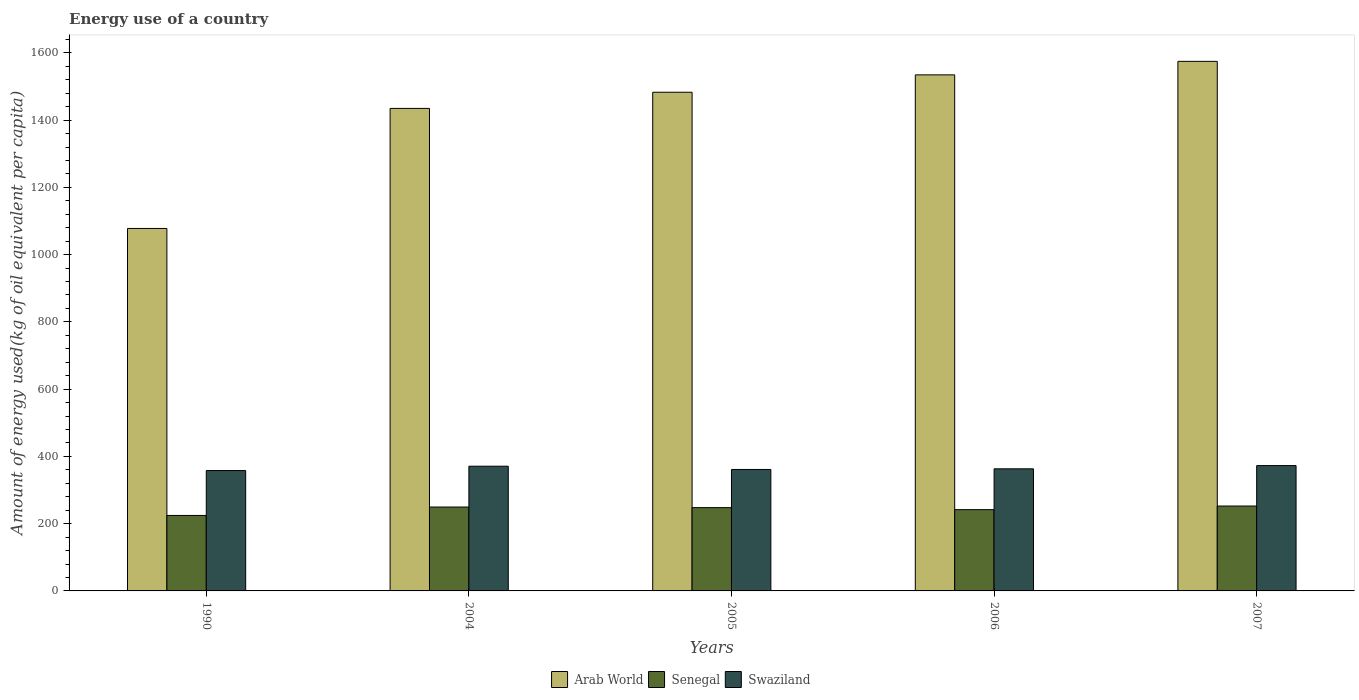How many different coloured bars are there?
Your answer should be very brief. 3. How many groups of bars are there?
Provide a succinct answer. 5. Are the number of bars per tick equal to the number of legend labels?
Keep it short and to the point. Yes. Are the number of bars on each tick of the X-axis equal?
Ensure brevity in your answer.  Yes. How many bars are there on the 2nd tick from the right?
Provide a short and direct response. 3. What is the amount of energy used in in Arab World in 2006?
Keep it short and to the point. 1534.62. Across all years, what is the maximum amount of energy used in in Senegal?
Offer a very short reply. 252.41. Across all years, what is the minimum amount of energy used in in Senegal?
Your answer should be very brief. 224.43. What is the total amount of energy used in in Senegal in the graph?
Offer a terse response. 1215.62. What is the difference between the amount of energy used in in Swaziland in 1990 and that in 2004?
Your answer should be very brief. -12.92. What is the difference between the amount of energy used in in Swaziland in 1990 and the amount of energy used in in Arab World in 2004?
Give a very brief answer. -1076.91. What is the average amount of energy used in in Senegal per year?
Ensure brevity in your answer.  243.12. In the year 2006, what is the difference between the amount of energy used in in Swaziland and amount of energy used in in Arab World?
Make the answer very short. -1171.54. What is the ratio of the amount of energy used in in Swaziland in 2005 to that in 2007?
Give a very brief answer. 0.97. Is the amount of energy used in in Arab World in 1990 less than that in 2004?
Your answer should be compact. Yes. What is the difference between the highest and the second highest amount of energy used in in Swaziland?
Provide a short and direct response. 1.88. What is the difference between the highest and the lowest amount of energy used in in Senegal?
Your answer should be compact. 27.98. In how many years, is the amount of energy used in in Senegal greater than the average amount of energy used in in Senegal taken over all years?
Give a very brief answer. 3. Is the sum of the amount of energy used in in Swaziland in 2004 and 2005 greater than the maximum amount of energy used in in Arab World across all years?
Your answer should be compact. No. What does the 3rd bar from the left in 2006 represents?
Offer a terse response. Swaziland. What does the 2nd bar from the right in 2006 represents?
Offer a terse response. Senegal. How many bars are there?
Provide a short and direct response. 15. Are all the bars in the graph horizontal?
Offer a very short reply. No. How many years are there in the graph?
Provide a succinct answer. 5. Are the values on the major ticks of Y-axis written in scientific E-notation?
Offer a very short reply. No. Does the graph contain any zero values?
Your answer should be compact. No. Where does the legend appear in the graph?
Your answer should be very brief. Bottom center. What is the title of the graph?
Your response must be concise. Energy use of a country. What is the label or title of the Y-axis?
Offer a very short reply. Amount of energy used(kg of oil equivalent per capita). What is the Amount of energy used(kg of oil equivalent per capita) of Arab World in 1990?
Offer a terse response. 1077.86. What is the Amount of energy used(kg of oil equivalent per capita) in Senegal in 1990?
Give a very brief answer. 224.43. What is the Amount of energy used(kg of oil equivalent per capita) of Swaziland in 1990?
Provide a succinct answer. 357.93. What is the Amount of energy used(kg of oil equivalent per capita) of Arab World in 2004?
Provide a succinct answer. 1434.84. What is the Amount of energy used(kg of oil equivalent per capita) of Senegal in 2004?
Ensure brevity in your answer.  249.43. What is the Amount of energy used(kg of oil equivalent per capita) in Swaziland in 2004?
Your answer should be very brief. 370.85. What is the Amount of energy used(kg of oil equivalent per capita) of Arab World in 2005?
Make the answer very short. 1482.94. What is the Amount of energy used(kg of oil equivalent per capita) of Senegal in 2005?
Provide a short and direct response. 247.66. What is the Amount of energy used(kg of oil equivalent per capita) in Swaziland in 2005?
Give a very brief answer. 361.2. What is the Amount of energy used(kg of oil equivalent per capita) of Arab World in 2006?
Offer a terse response. 1534.62. What is the Amount of energy used(kg of oil equivalent per capita) of Senegal in 2006?
Offer a very short reply. 241.68. What is the Amount of energy used(kg of oil equivalent per capita) in Swaziland in 2006?
Your answer should be compact. 363.08. What is the Amount of energy used(kg of oil equivalent per capita) of Arab World in 2007?
Your response must be concise. 1574.79. What is the Amount of energy used(kg of oil equivalent per capita) in Senegal in 2007?
Your response must be concise. 252.41. What is the Amount of energy used(kg of oil equivalent per capita) of Swaziland in 2007?
Give a very brief answer. 372.74. Across all years, what is the maximum Amount of energy used(kg of oil equivalent per capita) of Arab World?
Keep it short and to the point. 1574.79. Across all years, what is the maximum Amount of energy used(kg of oil equivalent per capita) of Senegal?
Offer a terse response. 252.41. Across all years, what is the maximum Amount of energy used(kg of oil equivalent per capita) of Swaziland?
Offer a very short reply. 372.74. Across all years, what is the minimum Amount of energy used(kg of oil equivalent per capita) of Arab World?
Your answer should be very brief. 1077.86. Across all years, what is the minimum Amount of energy used(kg of oil equivalent per capita) of Senegal?
Keep it short and to the point. 224.43. Across all years, what is the minimum Amount of energy used(kg of oil equivalent per capita) of Swaziland?
Offer a very short reply. 357.93. What is the total Amount of energy used(kg of oil equivalent per capita) in Arab World in the graph?
Give a very brief answer. 7105.06. What is the total Amount of energy used(kg of oil equivalent per capita) of Senegal in the graph?
Offer a terse response. 1215.62. What is the total Amount of energy used(kg of oil equivalent per capita) of Swaziland in the graph?
Provide a succinct answer. 1825.81. What is the difference between the Amount of energy used(kg of oil equivalent per capita) of Arab World in 1990 and that in 2004?
Ensure brevity in your answer.  -356.98. What is the difference between the Amount of energy used(kg of oil equivalent per capita) of Senegal in 1990 and that in 2004?
Make the answer very short. -25.01. What is the difference between the Amount of energy used(kg of oil equivalent per capita) of Swaziland in 1990 and that in 2004?
Ensure brevity in your answer.  -12.92. What is the difference between the Amount of energy used(kg of oil equivalent per capita) in Arab World in 1990 and that in 2005?
Make the answer very short. -405.08. What is the difference between the Amount of energy used(kg of oil equivalent per capita) of Senegal in 1990 and that in 2005?
Give a very brief answer. -23.23. What is the difference between the Amount of energy used(kg of oil equivalent per capita) of Swaziland in 1990 and that in 2005?
Your answer should be compact. -3.27. What is the difference between the Amount of energy used(kg of oil equivalent per capita) of Arab World in 1990 and that in 2006?
Make the answer very short. -456.76. What is the difference between the Amount of energy used(kg of oil equivalent per capita) in Senegal in 1990 and that in 2006?
Offer a terse response. -17.25. What is the difference between the Amount of energy used(kg of oil equivalent per capita) in Swaziland in 1990 and that in 2006?
Provide a succinct answer. -5.15. What is the difference between the Amount of energy used(kg of oil equivalent per capita) of Arab World in 1990 and that in 2007?
Your response must be concise. -496.93. What is the difference between the Amount of energy used(kg of oil equivalent per capita) of Senegal in 1990 and that in 2007?
Keep it short and to the point. -27.98. What is the difference between the Amount of energy used(kg of oil equivalent per capita) in Swaziland in 1990 and that in 2007?
Your answer should be compact. -14.8. What is the difference between the Amount of energy used(kg of oil equivalent per capita) in Arab World in 2004 and that in 2005?
Your response must be concise. -48.1. What is the difference between the Amount of energy used(kg of oil equivalent per capita) in Senegal in 2004 and that in 2005?
Make the answer very short. 1.77. What is the difference between the Amount of energy used(kg of oil equivalent per capita) in Swaziland in 2004 and that in 2005?
Make the answer very short. 9.65. What is the difference between the Amount of energy used(kg of oil equivalent per capita) in Arab World in 2004 and that in 2006?
Your response must be concise. -99.78. What is the difference between the Amount of energy used(kg of oil equivalent per capita) in Senegal in 2004 and that in 2006?
Offer a terse response. 7.75. What is the difference between the Amount of energy used(kg of oil equivalent per capita) of Swaziland in 2004 and that in 2006?
Provide a succinct answer. 7.77. What is the difference between the Amount of energy used(kg of oil equivalent per capita) of Arab World in 2004 and that in 2007?
Offer a terse response. -139.95. What is the difference between the Amount of energy used(kg of oil equivalent per capita) in Senegal in 2004 and that in 2007?
Keep it short and to the point. -2.98. What is the difference between the Amount of energy used(kg of oil equivalent per capita) in Swaziland in 2004 and that in 2007?
Ensure brevity in your answer.  -1.88. What is the difference between the Amount of energy used(kg of oil equivalent per capita) of Arab World in 2005 and that in 2006?
Your answer should be compact. -51.68. What is the difference between the Amount of energy used(kg of oil equivalent per capita) of Senegal in 2005 and that in 2006?
Your answer should be compact. 5.98. What is the difference between the Amount of energy used(kg of oil equivalent per capita) in Swaziland in 2005 and that in 2006?
Give a very brief answer. -1.88. What is the difference between the Amount of energy used(kg of oil equivalent per capita) of Arab World in 2005 and that in 2007?
Keep it short and to the point. -91.85. What is the difference between the Amount of energy used(kg of oil equivalent per capita) in Senegal in 2005 and that in 2007?
Provide a succinct answer. -4.75. What is the difference between the Amount of energy used(kg of oil equivalent per capita) in Swaziland in 2005 and that in 2007?
Provide a succinct answer. -11.53. What is the difference between the Amount of energy used(kg of oil equivalent per capita) of Arab World in 2006 and that in 2007?
Make the answer very short. -40.17. What is the difference between the Amount of energy used(kg of oil equivalent per capita) in Senegal in 2006 and that in 2007?
Your response must be concise. -10.73. What is the difference between the Amount of energy used(kg of oil equivalent per capita) of Swaziland in 2006 and that in 2007?
Make the answer very short. -9.65. What is the difference between the Amount of energy used(kg of oil equivalent per capita) in Arab World in 1990 and the Amount of energy used(kg of oil equivalent per capita) in Senegal in 2004?
Your answer should be compact. 828.43. What is the difference between the Amount of energy used(kg of oil equivalent per capita) in Arab World in 1990 and the Amount of energy used(kg of oil equivalent per capita) in Swaziland in 2004?
Provide a short and direct response. 707.01. What is the difference between the Amount of energy used(kg of oil equivalent per capita) of Senegal in 1990 and the Amount of energy used(kg of oil equivalent per capita) of Swaziland in 2004?
Give a very brief answer. -146.42. What is the difference between the Amount of energy used(kg of oil equivalent per capita) in Arab World in 1990 and the Amount of energy used(kg of oil equivalent per capita) in Senegal in 2005?
Provide a succinct answer. 830.2. What is the difference between the Amount of energy used(kg of oil equivalent per capita) of Arab World in 1990 and the Amount of energy used(kg of oil equivalent per capita) of Swaziland in 2005?
Provide a short and direct response. 716.66. What is the difference between the Amount of energy used(kg of oil equivalent per capita) of Senegal in 1990 and the Amount of energy used(kg of oil equivalent per capita) of Swaziland in 2005?
Provide a short and direct response. -136.78. What is the difference between the Amount of energy used(kg of oil equivalent per capita) of Arab World in 1990 and the Amount of energy used(kg of oil equivalent per capita) of Senegal in 2006?
Offer a very short reply. 836.18. What is the difference between the Amount of energy used(kg of oil equivalent per capita) in Arab World in 1990 and the Amount of energy used(kg of oil equivalent per capita) in Swaziland in 2006?
Make the answer very short. 714.78. What is the difference between the Amount of energy used(kg of oil equivalent per capita) in Senegal in 1990 and the Amount of energy used(kg of oil equivalent per capita) in Swaziland in 2006?
Make the answer very short. -138.65. What is the difference between the Amount of energy used(kg of oil equivalent per capita) in Arab World in 1990 and the Amount of energy used(kg of oil equivalent per capita) in Senegal in 2007?
Give a very brief answer. 825.45. What is the difference between the Amount of energy used(kg of oil equivalent per capita) of Arab World in 1990 and the Amount of energy used(kg of oil equivalent per capita) of Swaziland in 2007?
Your answer should be compact. 705.12. What is the difference between the Amount of energy used(kg of oil equivalent per capita) in Senegal in 1990 and the Amount of energy used(kg of oil equivalent per capita) in Swaziland in 2007?
Ensure brevity in your answer.  -148.31. What is the difference between the Amount of energy used(kg of oil equivalent per capita) in Arab World in 2004 and the Amount of energy used(kg of oil equivalent per capita) in Senegal in 2005?
Make the answer very short. 1187.18. What is the difference between the Amount of energy used(kg of oil equivalent per capita) of Arab World in 2004 and the Amount of energy used(kg of oil equivalent per capita) of Swaziland in 2005?
Offer a very short reply. 1073.64. What is the difference between the Amount of energy used(kg of oil equivalent per capita) in Senegal in 2004 and the Amount of energy used(kg of oil equivalent per capita) in Swaziland in 2005?
Your response must be concise. -111.77. What is the difference between the Amount of energy used(kg of oil equivalent per capita) in Arab World in 2004 and the Amount of energy used(kg of oil equivalent per capita) in Senegal in 2006?
Offer a terse response. 1193.16. What is the difference between the Amount of energy used(kg of oil equivalent per capita) in Arab World in 2004 and the Amount of energy used(kg of oil equivalent per capita) in Swaziland in 2006?
Provide a succinct answer. 1071.76. What is the difference between the Amount of energy used(kg of oil equivalent per capita) in Senegal in 2004 and the Amount of energy used(kg of oil equivalent per capita) in Swaziland in 2006?
Provide a succinct answer. -113.65. What is the difference between the Amount of energy used(kg of oil equivalent per capita) of Arab World in 2004 and the Amount of energy used(kg of oil equivalent per capita) of Senegal in 2007?
Your response must be concise. 1182.43. What is the difference between the Amount of energy used(kg of oil equivalent per capita) in Arab World in 2004 and the Amount of energy used(kg of oil equivalent per capita) in Swaziland in 2007?
Provide a succinct answer. 1062.11. What is the difference between the Amount of energy used(kg of oil equivalent per capita) of Senegal in 2004 and the Amount of energy used(kg of oil equivalent per capita) of Swaziland in 2007?
Your response must be concise. -123.3. What is the difference between the Amount of energy used(kg of oil equivalent per capita) of Arab World in 2005 and the Amount of energy used(kg of oil equivalent per capita) of Senegal in 2006?
Offer a terse response. 1241.26. What is the difference between the Amount of energy used(kg of oil equivalent per capita) of Arab World in 2005 and the Amount of energy used(kg of oil equivalent per capita) of Swaziland in 2006?
Give a very brief answer. 1119.86. What is the difference between the Amount of energy used(kg of oil equivalent per capita) of Senegal in 2005 and the Amount of energy used(kg of oil equivalent per capita) of Swaziland in 2006?
Offer a very short reply. -115.42. What is the difference between the Amount of energy used(kg of oil equivalent per capita) in Arab World in 2005 and the Amount of energy used(kg of oil equivalent per capita) in Senegal in 2007?
Make the answer very short. 1230.53. What is the difference between the Amount of energy used(kg of oil equivalent per capita) of Arab World in 2005 and the Amount of energy used(kg of oil equivalent per capita) of Swaziland in 2007?
Give a very brief answer. 1110.21. What is the difference between the Amount of energy used(kg of oil equivalent per capita) in Senegal in 2005 and the Amount of energy used(kg of oil equivalent per capita) in Swaziland in 2007?
Your response must be concise. -125.07. What is the difference between the Amount of energy used(kg of oil equivalent per capita) of Arab World in 2006 and the Amount of energy used(kg of oil equivalent per capita) of Senegal in 2007?
Offer a very short reply. 1282.21. What is the difference between the Amount of energy used(kg of oil equivalent per capita) of Arab World in 2006 and the Amount of energy used(kg of oil equivalent per capita) of Swaziland in 2007?
Give a very brief answer. 1161.89. What is the difference between the Amount of energy used(kg of oil equivalent per capita) of Senegal in 2006 and the Amount of energy used(kg of oil equivalent per capita) of Swaziland in 2007?
Keep it short and to the point. -131.05. What is the average Amount of energy used(kg of oil equivalent per capita) of Arab World per year?
Your answer should be very brief. 1421.01. What is the average Amount of energy used(kg of oil equivalent per capita) of Senegal per year?
Your response must be concise. 243.12. What is the average Amount of energy used(kg of oil equivalent per capita) of Swaziland per year?
Your answer should be compact. 365.16. In the year 1990, what is the difference between the Amount of energy used(kg of oil equivalent per capita) of Arab World and Amount of energy used(kg of oil equivalent per capita) of Senegal?
Provide a succinct answer. 853.43. In the year 1990, what is the difference between the Amount of energy used(kg of oil equivalent per capita) in Arab World and Amount of energy used(kg of oil equivalent per capita) in Swaziland?
Your answer should be very brief. 719.93. In the year 1990, what is the difference between the Amount of energy used(kg of oil equivalent per capita) in Senegal and Amount of energy used(kg of oil equivalent per capita) in Swaziland?
Make the answer very short. -133.5. In the year 2004, what is the difference between the Amount of energy used(kg of oil equivalent per capita) of Arab World and Amount of energy used(kg of oil equivalent per capita) of Senegal?
Your response must be concise. 1185.41. In the year 2004, what is the difference between the Amount of energy used(kg of oil equivalent per capita) in Arab World and Amount of energy used(kg of oil equivalent per capita) in Swaziland?
Your answer should be very brief. 1063.99. In the year 2004, what is the difference between the Amount of energy used(kg of oil equivalent per capita) of Senegal and Amount of energy used(kg of oil equivalent per capita) of Swaziland?
Your response must be concise. -121.42. In the year 2005, what is the difference between the Amount of energy used(kg of oil equivalent per capita) in Arab World and Amount of energy used(kg of oil equivalent per capita) in Senegal?
Your answer should be compact. 1235.28. In the year 2005, what is the difference between the Amount of energy used(kg of oil equivalent per capita) of Arab World and Amount of energy used(kg of oil equivalent per capita) of Swaziland?
Provide a succinct answer. 1121.74. In the year 2005, what is the difference between the Amount of energy used(kg of oil equivalent per capita) in Senegal and Amount of energy used(kg of oil equivalent per capita) in Swaziland?
Make the answer very short. -113.54. In the year 2006, what is the difference between the Amount of energy used(kg of oil equivalent per capita) of Arab World and Amount of energy used(kg of oil equivalent per capita) of Senegal?
Your response must be concise. 1292.94. In the year 2006, what is the difference between the Amount of energy used(kg of oil equivalent per capita) in Arab World and Amount of energy used(kg of oil equivalent per capita) in Swaziland?
Your response must be concise. 1171.54. In the year 2006, what is the difference between the Amount of energy used(kg of oil equivalent per capita) of Senegal and Amount of energy used(kg of oil equivalent per capita) of Swaziland?
Offer a terse response. -121.4. In the year 2007, what is the difference between the Amount of energy used(kg of oil equivalent per capita) in Arab World and Amount of energy used(kg of oil equivalent per capita) in Senegal?
Your answer should be very brief. 1322.38. In the year 2007, what is the difference between the Amount of energy used(kg of oil equivalent per capita) in Arab World and Amount of energy used(kg of oil equivalent per capita) in Swaziland?
Provide a succinct answer. 1202.06. In the year 2007, what is the difference between the Amount of energy used(kg of oil equivalent per capita) in Senegal and Amount of energy used(kg of oil equivalent per capita) in Swaziland?
Offer a very short reply. -120.33. What is the ratio of the Amount of energy used(kg of oil equivalent per capita) in Arab World in 1990 to that in 2004?
Your response must be concise. 0.75. What is the ratio of the Amount of energy used(kg of oil equivalent per capita) of Senegal in 1990 to that in 2004?
Give a very brief answer. 0.9. What is the ratio of the Amount of energy used(kg of oil equivalent per capita) of Swaziland in 1990 to that in 2004?
Your answer should be compact. 0.97. What is the ratio of the Amount of energy used(kg of oil equivalent per capita) in Arab World in 1990 to that in 2005?
Your answer should be very brief. 0.73. What is the ratio of the Amount of energy used(kg of oil equivalent per capita) of Senegal in 1990 to that in 2005?
Make the answer very short. 0.91. What is the ratio of the Amount of energy used(kg of oil equivalent per capita) of Swaziland in 1990 to that in 2005?
Your answer should be very brief. 0.99. What is the ratio of the Amount of energy used(kg of oil equivalent per capita) of Arab World in 1990 to that in 2006?
Provide a short and direct response. 0.7. What is the ratio of the Amount of energy used(kg of oil equivalent per capita) of Senegal in 1990 to that in 2006?
Your answer should be very brief. 0.93. What is the ratio of the Amount of energy used(kg of oil equivalent per capita) in Swaziland in 1990 to that in 2006?
Make the answer very short. 0.99. What is the ratio of the Amount of energy used(kg of oil equivalent per capita) of Arab World in 1990 to that in 2007?
Your answer should be compact. 0.68. What is the ratio of the Amount of energy used(kg of oil equivalent per capita) in Senegal in 1990 to that in 2007?
Offer a terse response. 0.89. What is the ratio of the Amount of energy used(kg of oil equivalent per capita) in Swaziland in 1990 to that in 2007?
Offer a terse response. 0.96. What is the ratio of the Amount of energy used(kg of oil equivalent per capita) of Arab World in 2004 to that in 2005?
Make the answer very short. 0.97. What is the ratio of the Amount of energy used(kg of oil equivalent per capita) in Swaziland in 2004 to that in 2005?
Ensure brevity in your answer.  1.03. What is the ratio of the Amount of energy used(kg of oil equivalent per capita) in Arab World in 2004 to that in 2006?
Ensure brevity in your answer.  0.94. What is the ratio of the Amount of energy used(kg of oil equivalent per capita) in Senegal in 2004 to that in 2006?
Offer a terse response. 1.03. What is the ratio of the Amount of energy used(kg of oil equivalent per capita) in Swaziland in 2004 to that in 2006?
Make the answer very short. 1.02. What is the ratio of the Amount of energy used(kg of oil equivalent per capita) in Arab World in 2004 to that in 2007?
Ensure brevity in your answer.  0.91. What is the ratio of the Amount of energy used(kg of oil equivalent per capita) of Swaziland in 2004 to that in 2007?
Provide a short and direct response. 0.99. What is the ratio of the Amount of energy used(kg of oil equivalent per capita) of Arab World in 2005 to that in 2006?
Make the answer very short. 0.97. What is the ratio of the Amount of energy used(kg of oil equivalent per capita) of Senegal in 2005 to that in 2006?
Offer a terse response. 1.02. What is the ratio of the Amount of energy used(kg of oil equivalent per capita) of Swaziland in 2005 to that in 2006?
Your answer should be very brief. 0.99. What is the ratio of the Amount of energy used(kg of oil equivalent per capita) of Arab World in 2005 to that in 2007?
Offer a terse response. 0.94. What is the ratio of the Amount of energy used(kg of oil equivalent per capita) in Senegal in 2005 to that in 2007?
Offer a very short reply. 0.98. What is the ratio of the Amount of energy used(kg of oil equivalent per capita) in Swaziland in 2005 to that in 2007?
Your response must be concise. 0.97. What is the ratio of the Amount of energy used(kg of oil equivalent per capita) in Arab World in 2006 to that in 2007?
Offer a very short reply. 0.97. What is the ratio of the Amount of energy used(kg of oil equivalent per capita) in Senegal in 2006 to that in 2007?
Your answer should be very brief. 0.96. What is the ratio of the Amount of energy used(kg of oil equivalent per capita) in Swaziland in 2006 to that in 2007?
Your answer should be compact. 0.97. What is the difference between the highest and the second highest Amount of energy used(kg of oil equivalent per capita) of Arab World?
Keep it short and to the point. 40.17. What is the difference between the highest and the second highest Amount of energy used(kg of oil equivalent per capita) in Senegal?
Your answer should be very brief. 2.98. What is the difference between the highest and the second highest Amount of energy used(kg of oil equivalent per capita) of Swaziland?
Your answer should be very brief. 1.88. What is the difference between the highest and the lowest Amount of energy used(kg of oil equivalent per capita) in Arab World?
Make the answer very short. 496.93. What is the difference between the highest and the lowest Amount of energy used(kg of oil equivalent per capita) in Senegal?
Your response must be concise. 27.98. What is the difference between the highest and the lowest Amount of energy used(kg of oil equivalent per capita) in Swaziland?
Give a very brief answer. 14.8. 